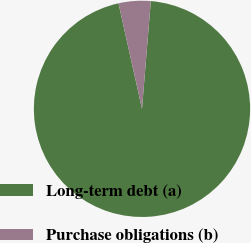Convert chart. <chart><loc_0><loc_0><loc_500><loc_500><pie_chart><fcel>Long-term debt (a)<fcel>Purchase obligations (b)<nl><fcel>95.21%<fcel>4.79%<nl></chart> 